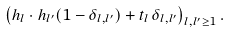<formula> <loc_0><loc_0><loc_500><loc_500>\left ( h _ { l } \cdot h _ { l ^ { \prime } } ( 1 - \delta _ { l , l ^ { \prime } } ) + t _ { l } \, \delta _ { l , l ^ { \prime } } \right ) _ { l , l ^ { \prime } \geq 1 } .</formula> 